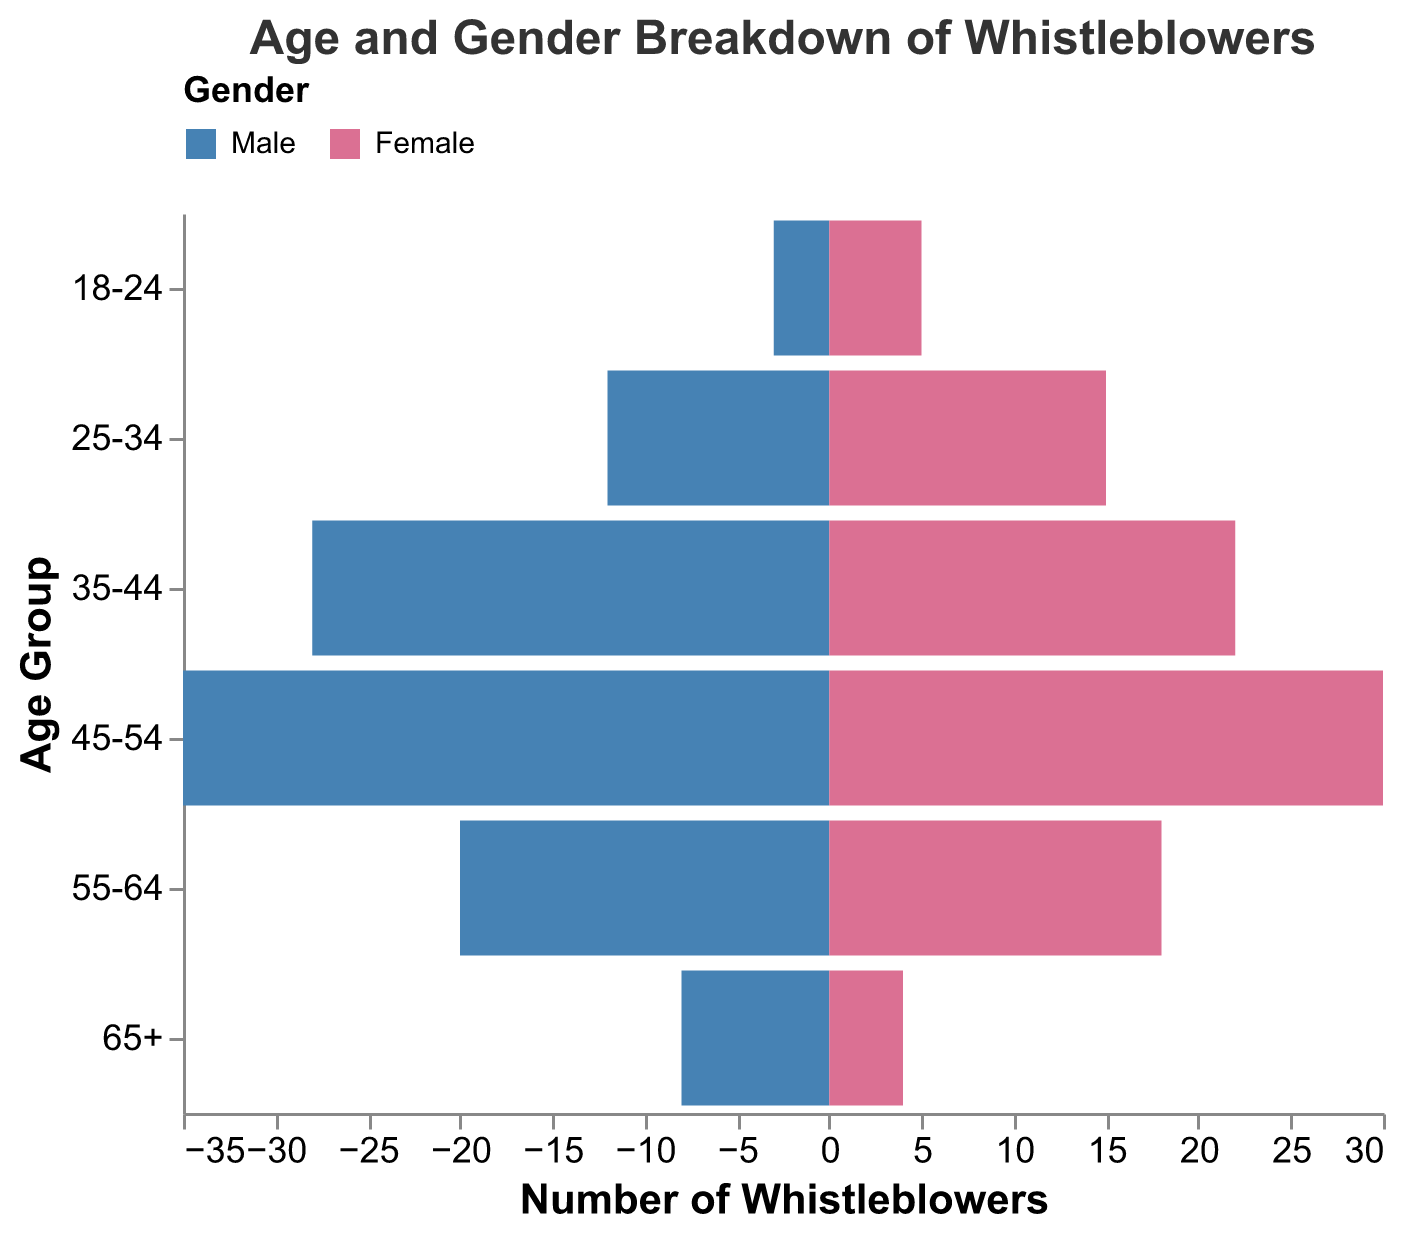What's the title of the figure? The title of the figure is displayed at the top and reads "Age and Gender Breakdown of Whistleblowers".
Answer: Age and Gender Breakdown of Whistleblowers What are the age groups available in the figure? The age groups are displayed along the y-axis and include "18-24", "25-34", "35-44", "45-54", "55-64", and "65+".
Answer: 18-24, 25-34, 35-44, 45-54, 55-64, 65+ Which gender has more whistleblowers in the 45-54 age group? By observing the bars corresponding to the 45-54 age group, the number of male whistleblowers (35) is greater than the number of female whistleblowers (30).
Answer: Male What is the total number of whistleblowers in the 35-44 age group? Sum the values for both Male (28) and Female (22) whistleblowers for this age group: 28 + 22 = 50.
Answer: 50 Which age group has the highest number of female whistleblowers? By comparing the lengths of the pink bars (Female) across all age groups, the 25-34 age group has the highest number with 15 female whistleblowers.
Answer: 25-34 How many more male whistleblowers are there than female whistleblowers in the 55-64 age group? Subtract the number of female whistleblowers (18) from the number of male whistleblowers (20) in this age group: 20 - 18 = 2.
Answer: 2 What is the ratio of male to female whistleblowers in the 18-24 age group? Divide the number of male whistleblowers (3) by the number of female whistleblowers (5) in this age group to get the ratio: 3/5 = 0.6.
Answer: 0.6 Among all age groups, which has the fewest whistleblowers for both genders combined? Sum the male and female whistleblowers for each age group, and the 18-24 age group has the fewest with a total of 8 (3 males + 5 females).
Answer: 18-24 What is the most significant gender difference in any age group, and what is the difference? Subtract female values from male values (or vice versa) for each age group and identify the largest difference. The 45-54 age group has the most significant difference: 35 (Male) - 30 (Female) = 5.
Answer: 5, in the 45-54 age group 